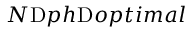Convert formula to latex. <formula><loc_0><loc_0><loc_500><loc_500>N p h o p t i m a l</formula> 